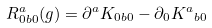<formula> <loc_0><loc_0><loc_500><loc_500>R ^ { a } _ { { 0 } { b } { 0 } } ( g ) = { \partial } ^ { a } { K _ { 0 b 0 } } - { \partial } _ { 0 } { { K } ^ { a } } _ { b 0 }</formula> 